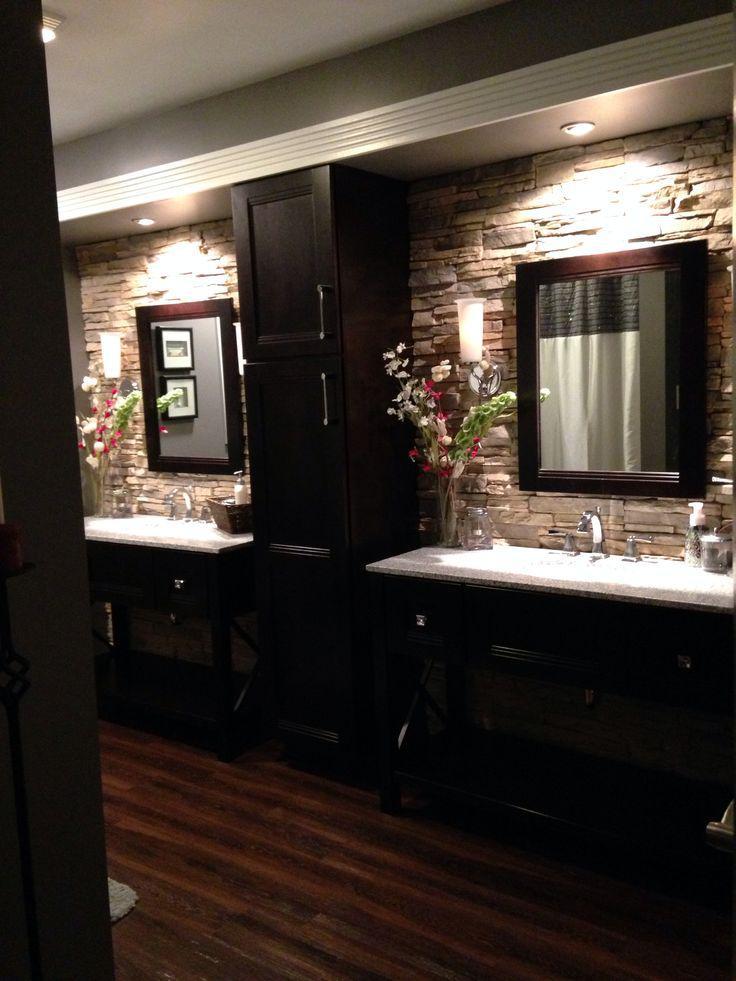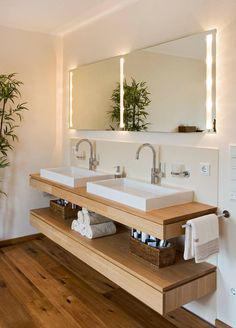The first image is the image on the left, the second image is the image on the right. For the images displayed, is the sentence "All of the bathrooms have double sinks." factually correct? Answer yes or no. Yes. The first image is the image on the left, the second image is the image on the right. For the images shown, is this caption "a toilet can be seen" true? Answer yes or no. No. 